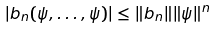<formula> <loc_0><loc_0><loc_500><loc_500>| b _ { n } ( \psi , \dots , \psi ) | \leq \| b _ { n } \| \| \psi \| ^ { n }</formula> 